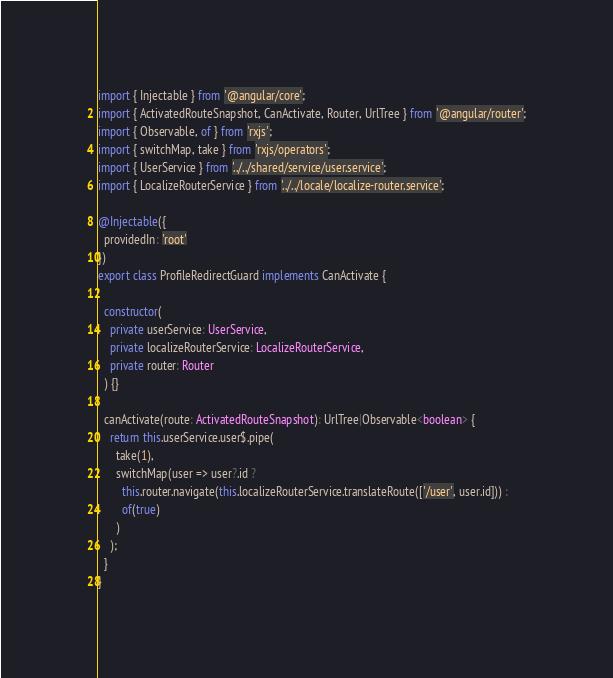Convert code to text. <code><loc_0><loc_0><loc_500><loc_500><_TypeScript_>import { Injectable } from '@angular/core';
import { ActivatedRouteSnapshot, CanActivate, Router, UrlTree } from '@angular/router';
import { Observable, of } from 'rxjs';
import { switchMap, take } from 'rxjs/operators';
import { UserService } from '../../shared/service/user.service';
import { LocalizeRouterService } from '../../locale/localize-router.service';

@Injectable({
  providedIn: 'root'
})
export class ProfileRedirectGuard implements CanActivate {

  constructor(
    private userService: UserService,
    private localizeRouterService: LocalizeRouterService,
    private router: Router
  ) {}

  canActivate(route: ActivatedRouteSnapshot): UrlTree|Observable<boolean> {
    return this.userService.user$.pipe(
      take(1),
      switchMap(user => user?.id ?
        this.router.navigate(this.localizeRouterService.translateRoute(['/user', user.id])) :
        of(true)
      )
    );
  }
}
</code> 